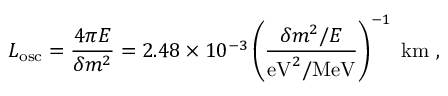Convert formula to latex. <formula><loc_0><loc_0><loc_500><loc_500>L _ { o s c } = \frac { 4 \pi E } { \delta m ^ { 2 } } = 2 . 4 8 \times 1 0 ^ { - 3 } \left ( \frac { \delta m ^ { 2 } / E } { e V ^ { 2 } / M e V } \right ) ^ { - 1 } \, k m \ ,</formula> 